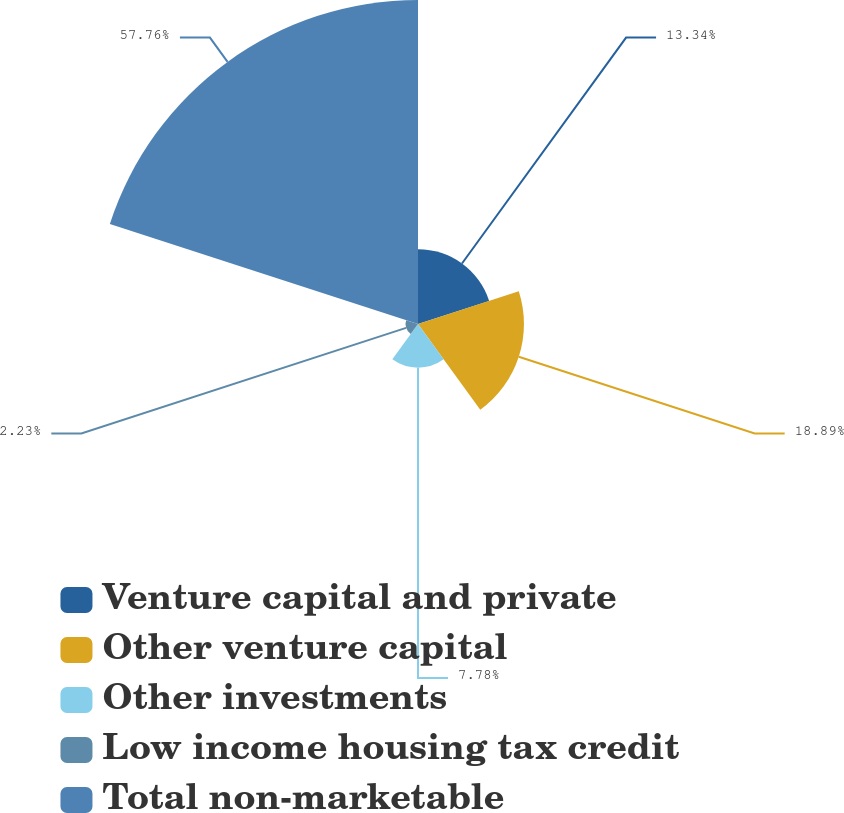<chart> <loc_0><loc_0><loc_500><loc_500><pie_chart><fcel>Venture capital and private<fcel>Other venture capital<fcel>Other investments<fcel>Low income housing tax credit<fcel>Total non-marketable<nl><fcel>13.34%<fcel>18.89%<fcel>7.78%<fcel>2.23%<fcel>57.77%<nl></chart> 